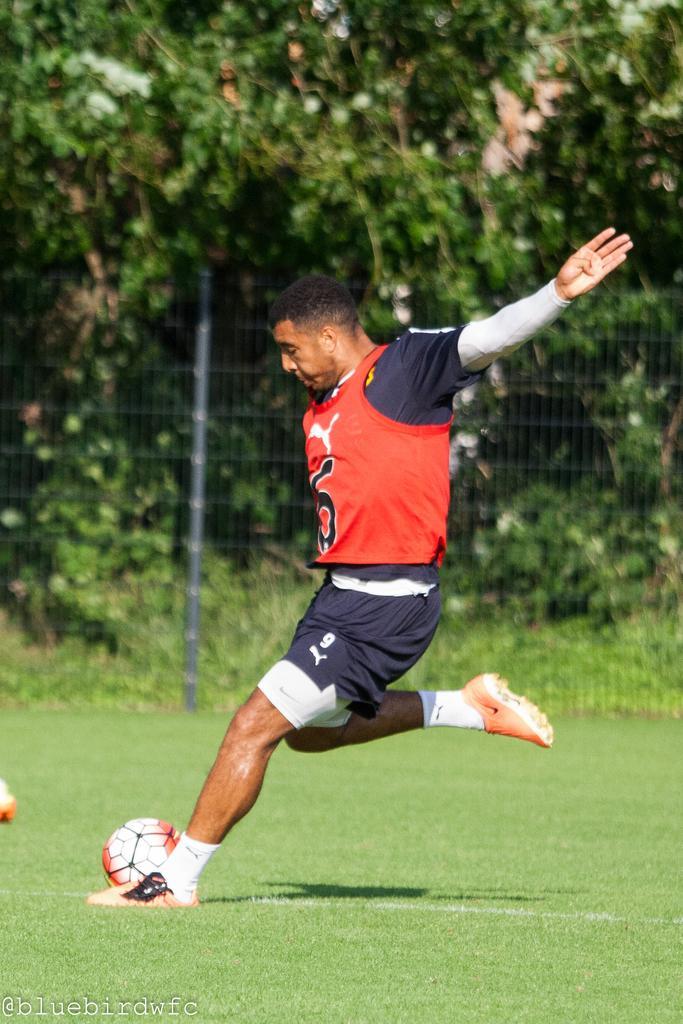How would you summarize this image in a sentence or two? This picture is clicked in the ground. The man in red and blue t-shirt is playing football in the ground and the ball is in white and red color. In front, we see grass in the ground. Behind him, we see fence. Behind the fence, we see trees. 